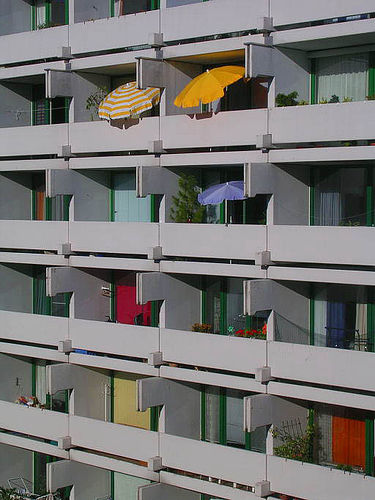<image>
Can you confirm if the door knob is on the door? Yes. Looking at the image, I can see the door knob is positioned on top of the door, with the door providing support. 